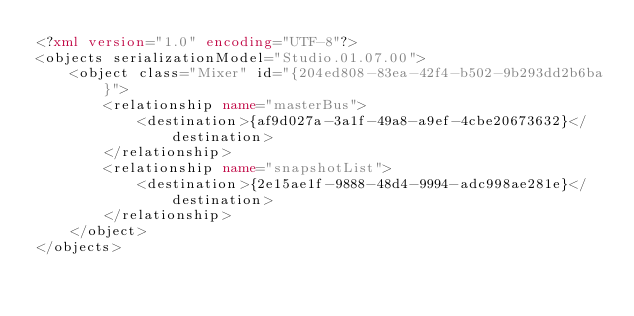Convert code to text. <code><loc_0><loc_0><loc_500><loc_500><_XML_><?xml version="1.0" encoding="UTF-8"?>
<objects serializationModel="Studio.01.07.00">
    <object class="Mixer" id="{204ed808-83ea-42f4-b502-9b293dd2b6ba}">
        <relationship name="masterBus">
            <destination>{af9d027a-3a1f-49a8-a9ef-4cbe20673632}</destination>
        </relationship>
        <relationship name="snapshotList">
            <destination>{2e15ae1f-9888-48d4-9994-adc998ae281e}</destination>
        </relationship>
    </object>
</objects>
</code> 